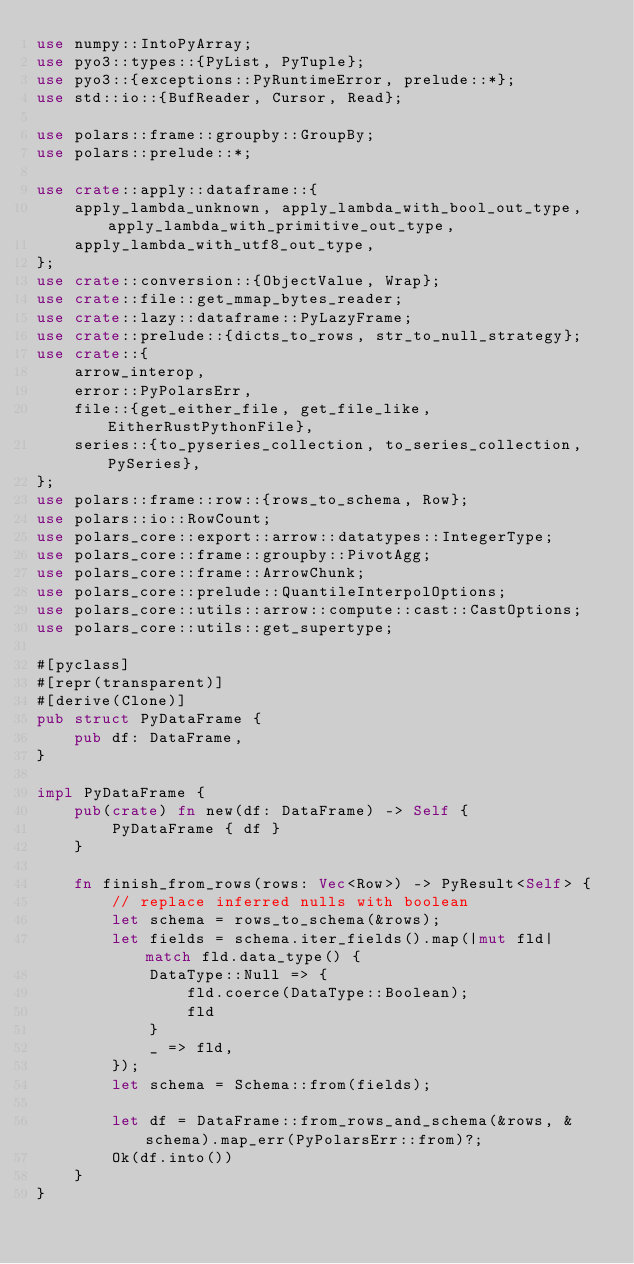Convert code to text. <code><loc_0><loc_0><loc_500><loc_500><_Rust_>use numpy::IntoPyArray;
use pyo3::types::{PyList, PyTuple};
use pyo3::{exceptions::PyRuntimeError, prelude::*};
use std::io::{BufReader, Cursor, Read};

use polars::frame::groupby::GroupBy;
use polars::prelude::*;

use crate::apply::dataframe::{
    apply_lambda_unknown, apply_lambda_with_bool_out_type, apply_lambda_with_primitive_out_type,
    apply_lambda_with_utf8_out_type,
};
use crate::conversion::{ObjectValue, Wrap};
use crate::file::get_mmap_bytes_reader;
use crate::lazy::dataframe::PyLazyFrame;
use crate::prelude::{dicts_to_rows, str_to_null_strategy};
use crate::{
    arrow_interop,
    error::PyPolarsErr,
    file::{get_either_file, get_file_like, EitherRustPythonFile},
    series::{to_pyseries_collection, to_series_collection, PySeries},
};
use polars::frame::row::{rows_to_schema, Row};
use polars::io::RowCount;
use polars_core::export::arrow::datatypes::IntegerType;
use polars_core::frame::groupby::PivotAgg;
use polars_core::frame::ArrowChunk;
use polars_core::prelude::QuantileInterpolOptions;
use polars_core::utils::arrow::compute::cast::CastOptions;
use polars_core::utils::get_supertype;

#[pyclass]
#[repr(transparent)]
#[derive(Clone)]
pub struct PyDataFrame {
    pub df: DataFrame,
}

impl PyDataFrame {
    pub(crate) fn new(df: DataFrame) -> Self {
        PyDataFrame { df }
    }

    fn finish_from_rows(rows: Vec<Row>) -> PyResult<Self> {
        // replace inferred nulls with boolean
        let schema = rows_to_schema(&rows);
        let fields = schema.iter_fields().map(|mut fld| match fld.data_type() {
            DataType::Null => {
                fld.coerce(DataType::Boolean);
                fld
            }
            _ => fld,
        });
        let schema = Schema::from(fields);

        let df = DataFrame::from_rows_and_schema(&rows, &schema).map_err(PyPolarsErr::from)?;
        Ok(df.into())
    }
}
</code> 